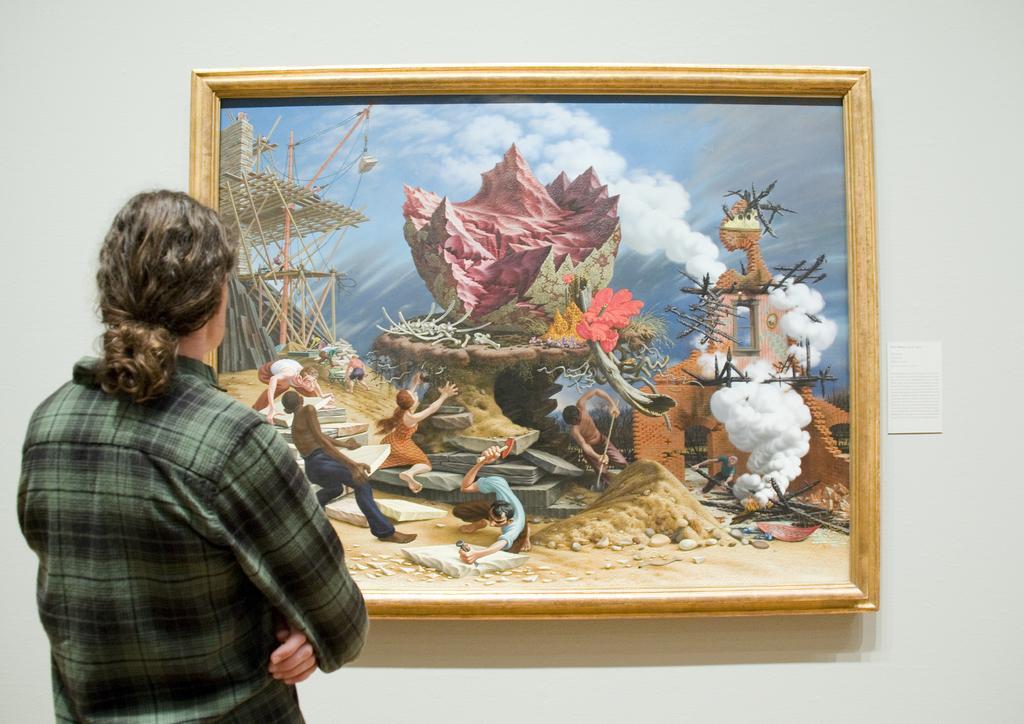In one or two sentences, can you explain what this image depicts? In this image we can see a person wearing a shirt is looking at a photo frame on the wall. In the photo we can see group of people standing on the ground. One person is holding a hammer in his hand. One woman is holding a statue with her hand. 